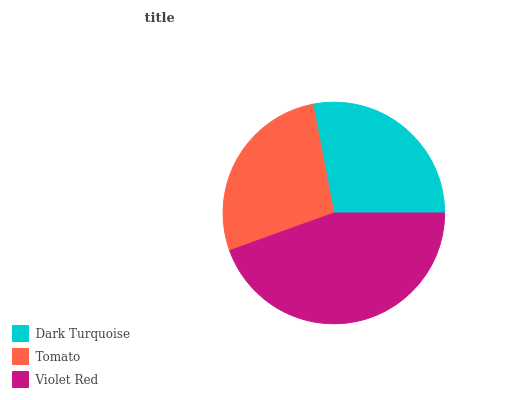Is Tomato the minimum?
Answer yes or no. Yes. Is Violet Red the maximum?
Answer yes or no. Yes. Is Violet Red the minimum?
Answer yes or no. No. Is Tomato the maximum?
Answer yes or no. No. Is Violet Red greater than Tomato?
Answer yes or no. Yes. Is Tomato less than Violet Red?
Answer yes or no. Yes. Is Tomato greater than Violet Red?
Answer yes or no. No. Is Violet Red less than Tomato?
Answer yes or no. No. Is Dark Turquoise the high median?
Answer yes or no. Yes. Is Dark Turquoise the low median?
Answer yes or no. Yes. Is Violet Red the high median?
Answer yes or no. No. Is Violet Red the low median?
Answer yes or no. No. 